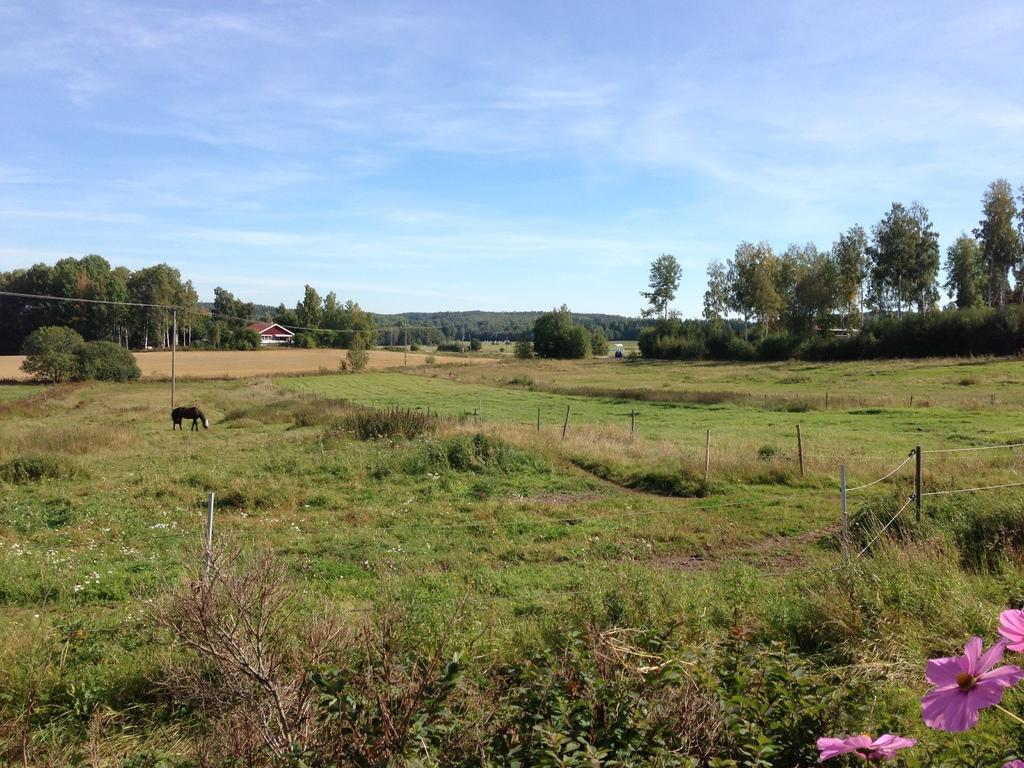What type of vegetation can be seen in the image? There are trees, plants, and grass in the image. What structure is present in the image? There is a pole and a house in the image. What animal can be seen in the image? There is a horse in the image. What part of the natural environment is visible in the image? The sky is visible in the image. What can be seen in the sky in the image? There are clouds in the image. What type of lock is used to secure the horse in the image? There is no lock present in the image, and the horse is not secured. What religious symbols can be seen in the image? There are no religious symbols present in the image. 